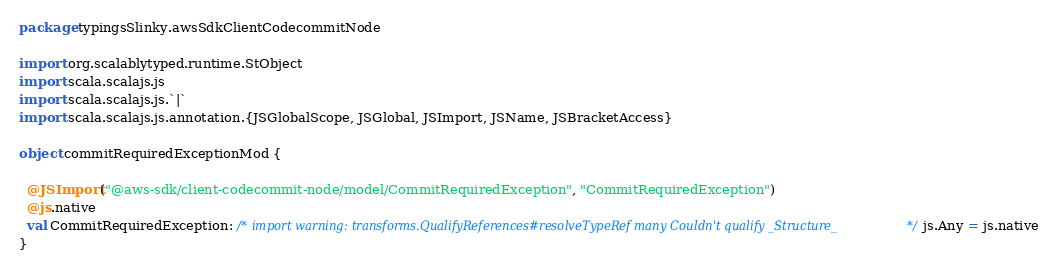<code> <loc_0><loc_0><loc_500><loc_500><_Scala_>package typingsSlinky.awsSdkClientCodecommitNode

import org.scalablytyped.runtime.StObject
import scala.scalajs.js
import scala.scalajs.js.`|`
import scala.scalajs.js.annotation.{JSGlobalScope, JSGlobal, JSImport, JSName, JSBracketAccess}

object commitRequiredExceptionMod {
  
  @JSImport("@aws-sdk/client-codecommit-node/model/CommitRequiredException", "CommitRequiredException")
  @js.native
  val CommitRequiredException: /* import warning: transforms.QualifyReferences#resolveTypeRef many Couldn't qualify _Structure_ */ js.Any = js.native
}
</code> 